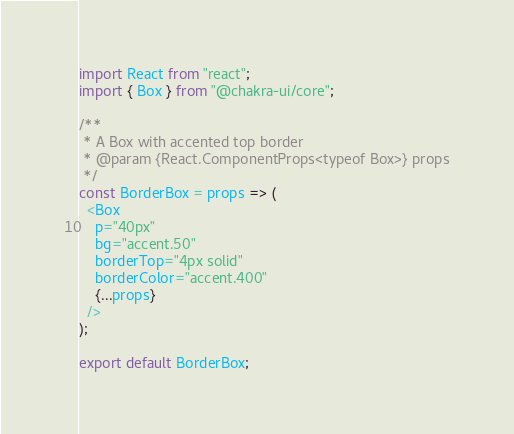<code> <loc_0><loc_0><loc_500><loc_500><_JavaScript_>import React from "react";
import { Box } from "@chakra-ui/core";

/**
 * A Box with accented top border
 * @param {React.ComponentProps<typeof Box>} props
 */
const BorderBox = props => (
  <Box
    p="40px"
    bg="accent.50"
    borderTop="4px solid"
    borderColor="accent.400"
    {...props}
  />
);

export default BorderBox;
</code> 